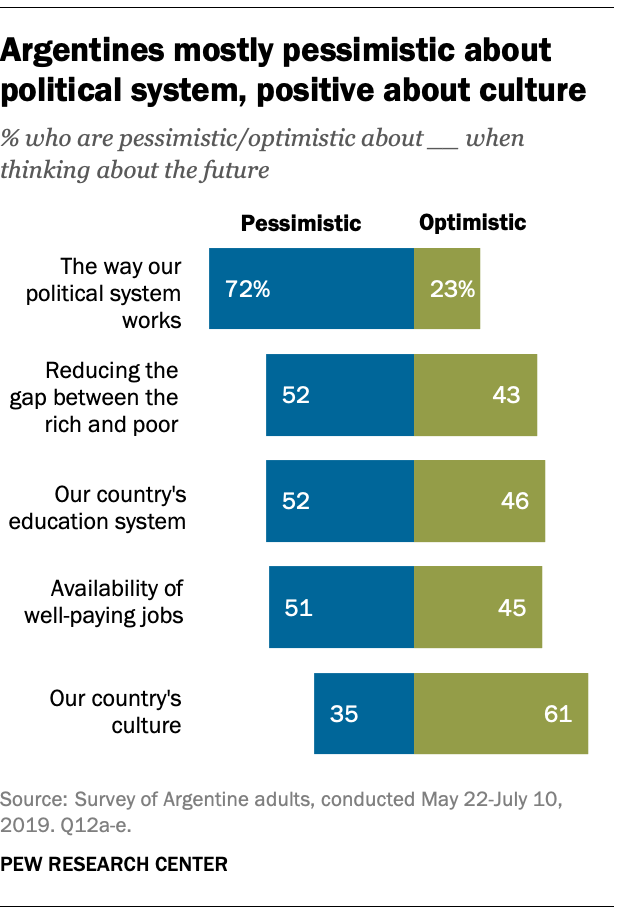Draw attention to some important aspects in this diagram. Of the values in the green bar, how many are above 40? The green bar has a lowest percentage value of 23%. 